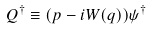Convert formula to latex. <formula><loc_0><loc_0><loc_500><loc_500>Q ^ { \dagger } \equiv ( p - i W ( q ) ) \psi ^ { \dagger }</formula> 